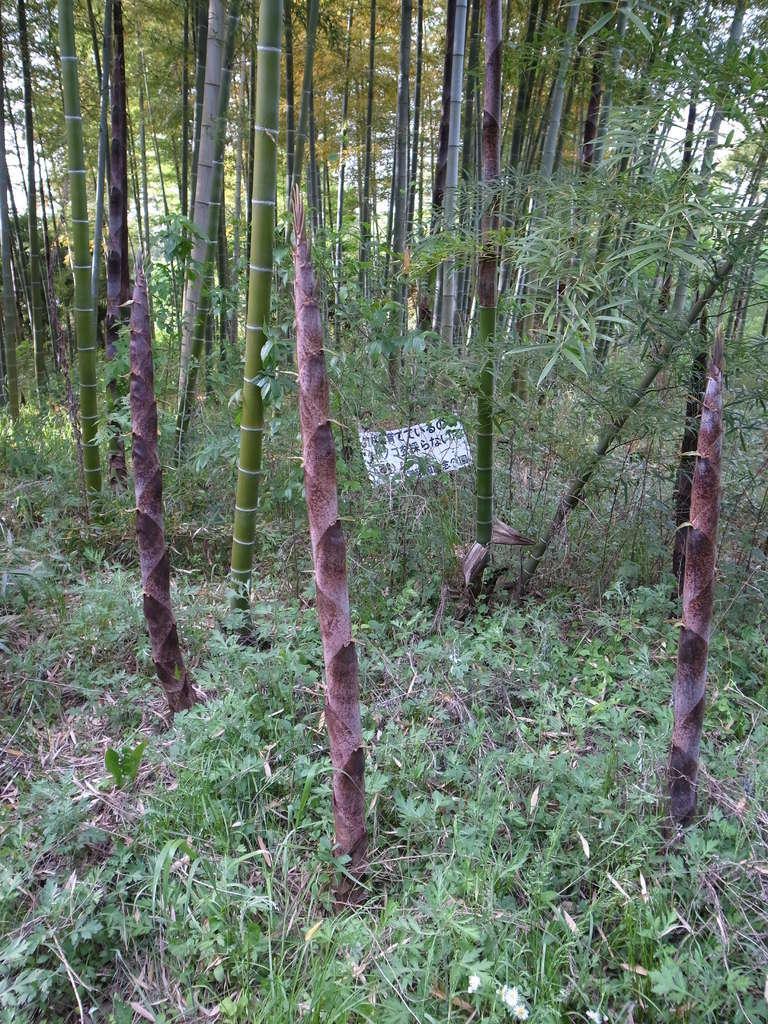How would you summarize this image in a sentence or two? In this picture I can see there is some grass, plants and there are few trees in the backdrop, there is a board in between the trees. 